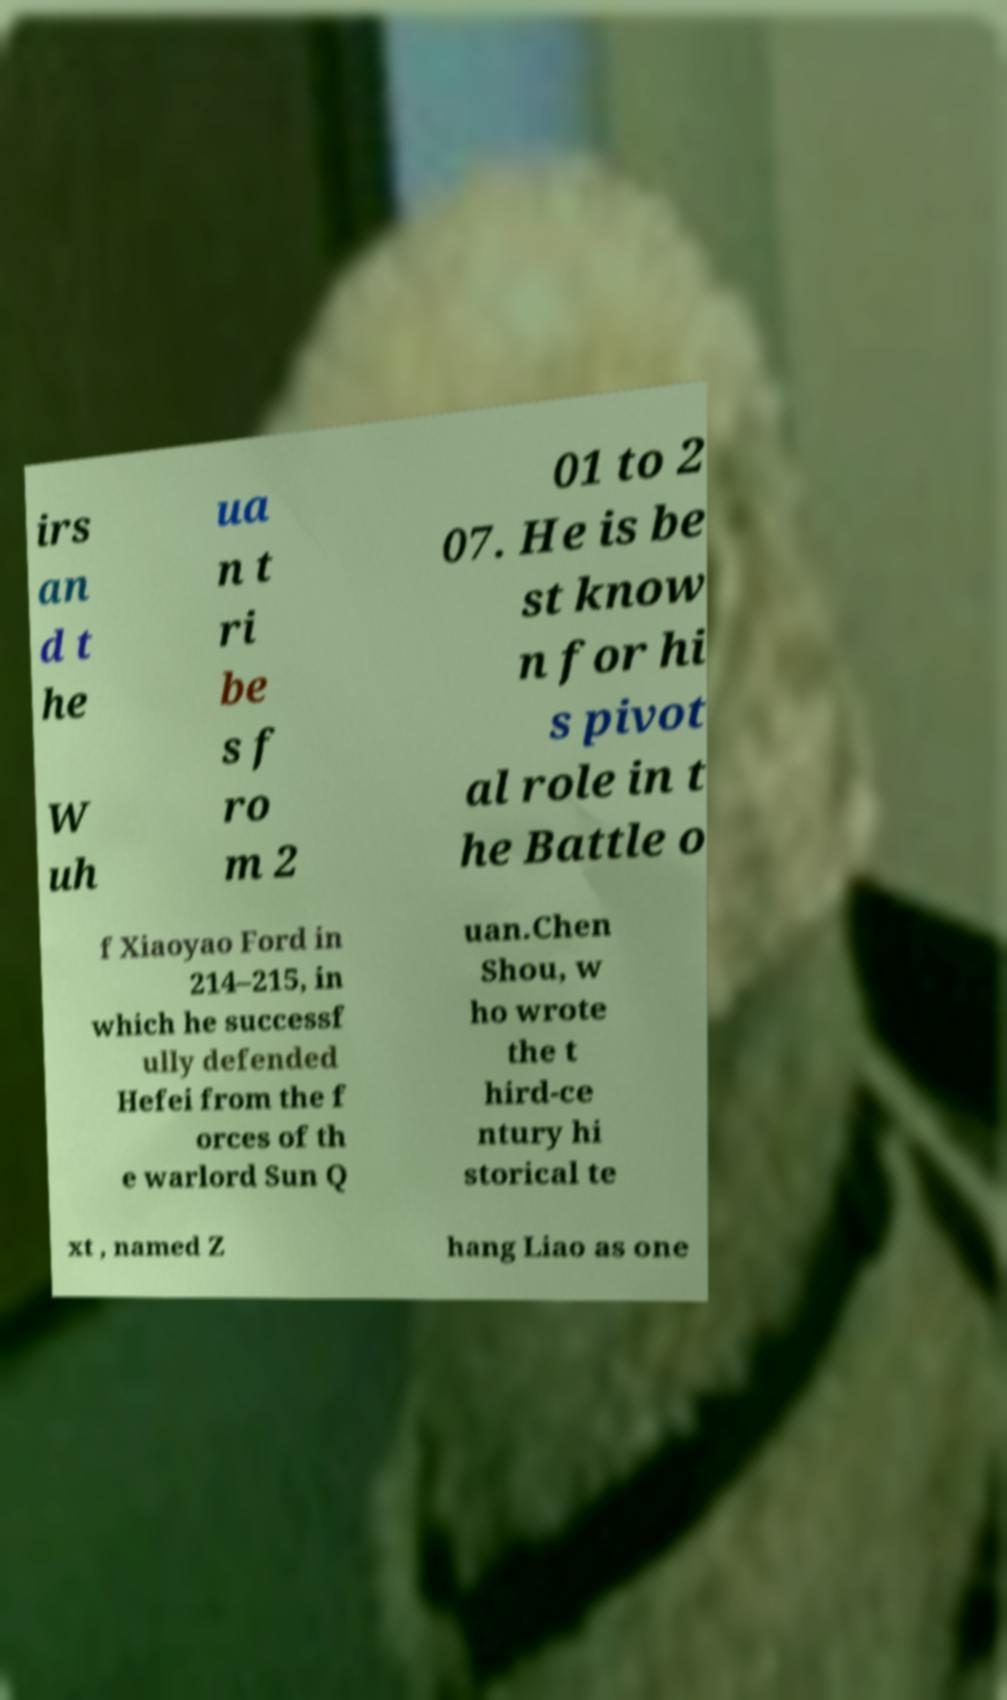Could you extract and type out the text from this image? irs an d t he W uh ua n t ri be s f ro m 2 01 to 2 07. He is be st know n for hi s pivot al role in t he Battle o f Xiaoyao Ford in 214–215, in which he successf ully defended Hefei from the f orces of th e warlord Sun Q uan.Chen Shou, w ho wrote the t hird-ce ntury hi storical te xt , named Z hang Liao as one 